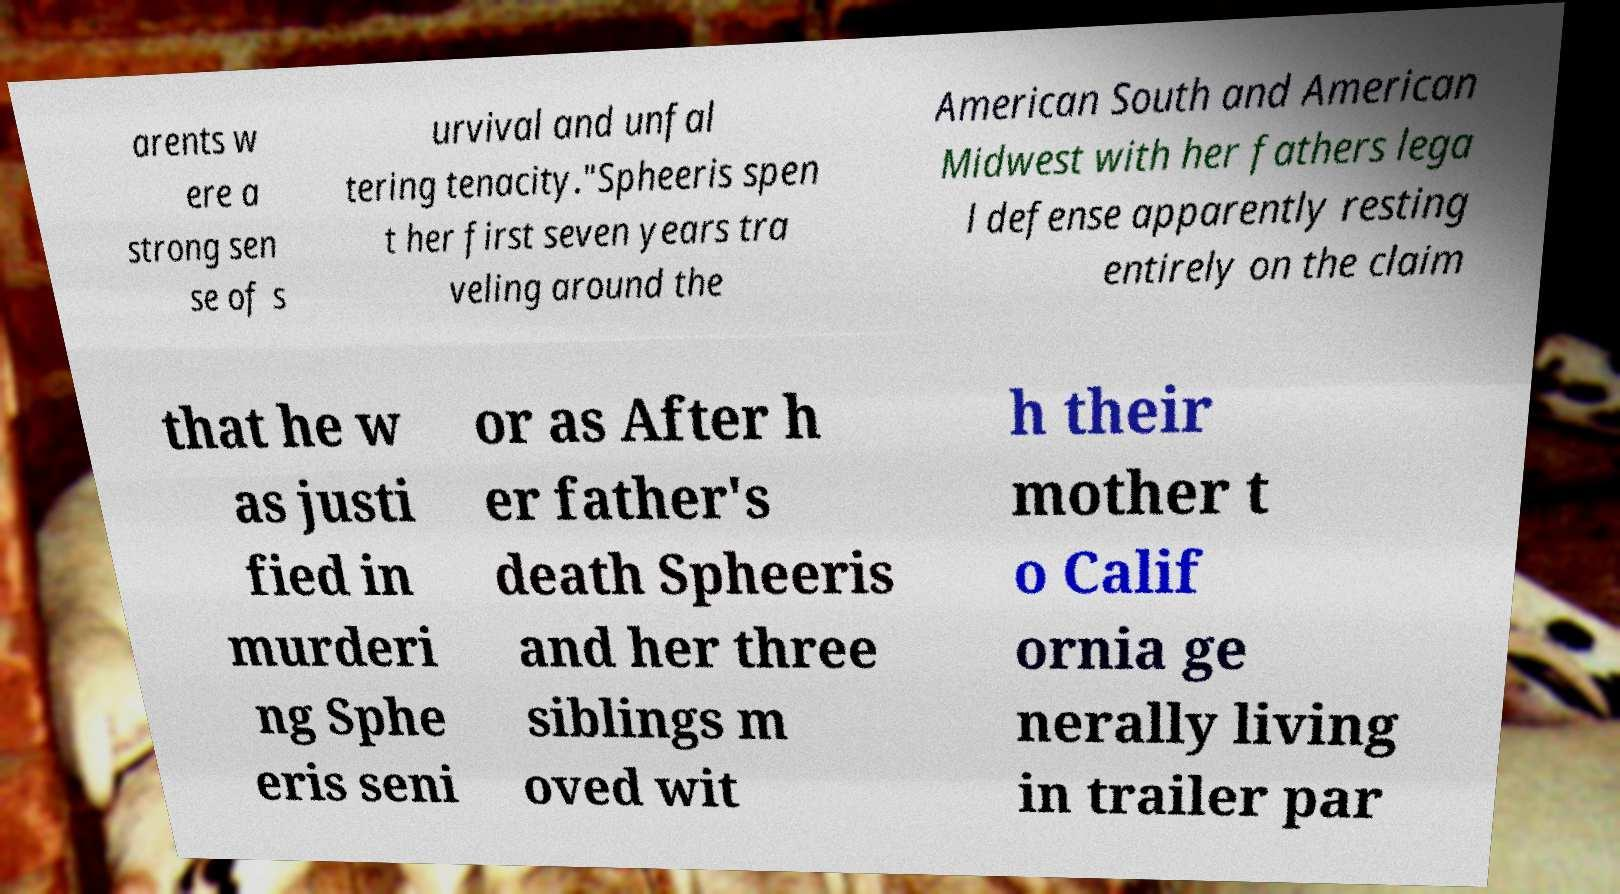What messages or text are displayed in this image? I need them in a readable, typed format. arents w ere a strong sen se of s urvival and unfal tering tenacity."Spheeris spen t her first seven years tra veling around the American South and American Midwest with her fathers lega l defense apparently resting entirely on the claim that he w as justi fied in murderi ng Sphe eris seni or as After h er father's death Spheeris and her three siblings m oved wit h their mother t o Calif ornia ge nerally living in trailer par 